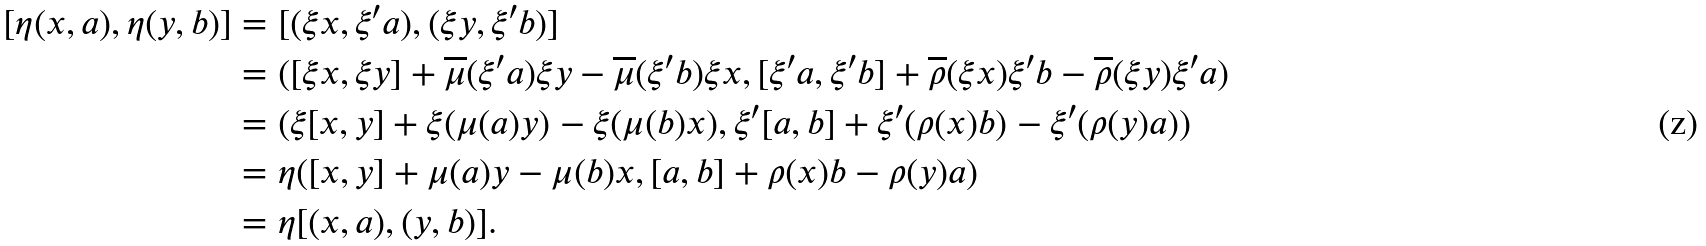<formula> <loc_0><loc_0><loc_500><loc_500>[ \eta ( x , a ) , \eta ( y , b ) ] & = [ ( \xi x , \xi ^ { \prime } a ) , ( \xi y , \xi ^ { \prime } b ) ] \\ & = ( [ \xi x , \xi y ] + \overline { \mu } ( \xi ^ { \prime } a ) \xi y - \overline { \mu } ( \xi ^ { \prime } b ) \xi x , [ \xi ^ { \prime } a , \xi ^ { \prime } b ] + \overline { \rho } ( \xi x ) \xi ^ { \prime } b - \overline { \rho } ( \xi y ) \xi ^ { \prime } a ) \\ & = ( \xi [ x , y ] + \xi ( \mu ( a ) y ) - \xi ( \mu ( b ) x ) , \xi ^ { \prime } [ a , b ] + \xi ^ { \prime } ( \rho ( x ) b ) - \xi ^ { \prime } ( \rho ( y ) a ) ) \\ & = \eta ( [ x , y ] + \mu ( a ) y - \mu ( b ) x , [ a , b ] + \rho ( x ) b - \rho ( y ) a ) \\ & = \eta [ ( x , a ) , ( y , b ) ] .</formula> 